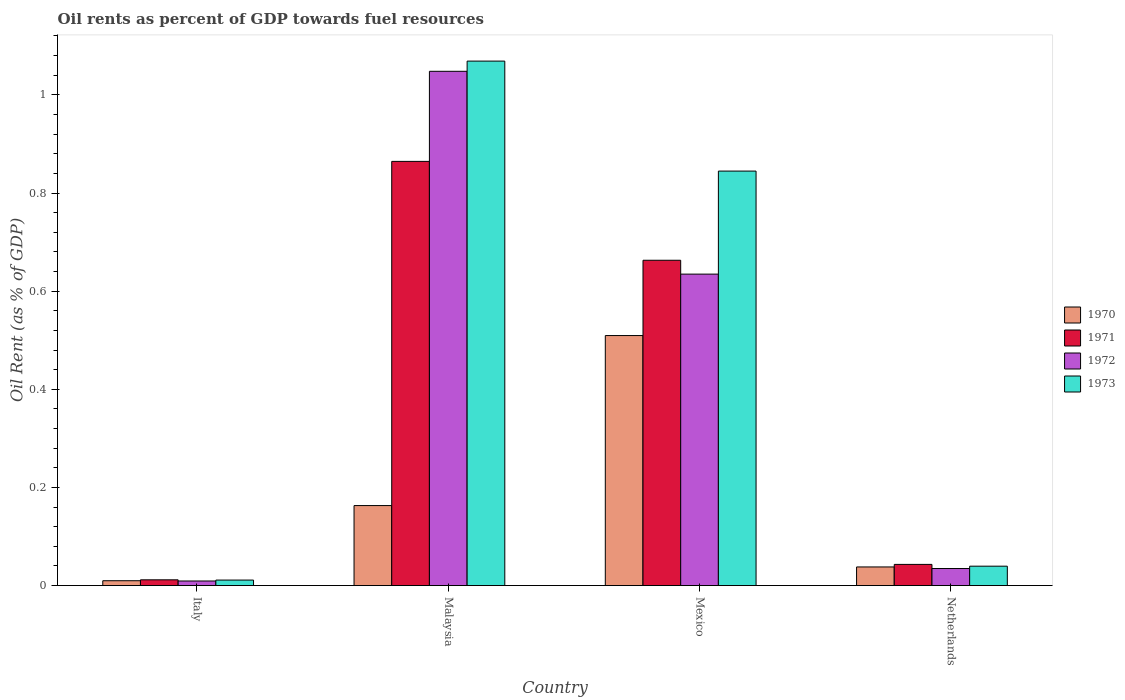Are the number of bars per tick equal to the number of legend labels?
Provide a succinct answer. Yes. Are the number of bars on each tick of the X-axis equal?
Ensure brevity in your answer.  Yes. How many bars are there on the 3rd tick from the left?
Keep it short and to the point. 4. What is the oil rent in 1972 in Italy?
Provide a short and direct response. 0.01. Across all countries, what is the maximum oil rent in 1970?
Offer a terse response. 0.51. Across all countries, what is the minimum oil rent in 1973?
Give a very brief answer. 0.01. In which country was the oil rent in 1972 maximum?
Offer a terse response. Malaysia. In which country was the oil rent in 1970 minimum?
Make the answer very short. Italy. What is the total oil rent in 1971 in the graph?
Make the answer very short. 1.58. What is the difference between the oil rent in 1971 in Malaysia and that in Netherlands?
Offer a terse response. 0.82. What is the difference between the oil rent in 1971 in Mexico and the oil rent in 1970 in Malaysia?
Provide a succinct answer. 0.5. What is the average oil rent in 1970 per country?
Give a very brief answer. 0.18. What is the difference between the oil rent of/in 1972 and oil rent of/in 1973 in Malaysia?
Offer a very short reply. -0.02. In how many countries, is the oil rent in 1971 greater than 0.6400000000000001 %?
Offer a terse response. 2. What is the ratio of the oil rent in 1970 in Italy to that in Netherlands?
Your answer should be compact. 0.26. Is the oil rent in 1971 in Mexico less than that in Netherlands?
Your answer should be very brief. No. Is the difference between the oil rent in 1972 in Mexico and Netherlands greater than the difference between the oil rent in 1973 in Mexico and Netherlands?
Keep it short and to the point. No. What is the difference between the highest and the second highest oil rent in 1971?
Provide a succinct answer. 0.2. What is the difference between the highest and the lowest oil rent in 1971?
Ensure brevity in your answer.  0.85. In how many countries, is the oil rent in 1971 greater than the average oil rent in 1971 taken over all countries?
Offer a very short reply. 2. Is it the case that in every country, the sum of the oil rent in 1971 and oil rent in 1970 is greater than the sum of oil rent in 1972 and oil rent in 1973?
Make the answer very short. No. What does the 2nd bar from the left in Netherlands represents?
Your answer should be compact. 1971. How many bars are there?
Offer a very short reply. 16. Are all the bars in the graph horizontal?
Your answer should be compact. No. How many countries are there in the graph?
Your answer should be very brief. 4. What is the difference between two consecutive major ticks on the Y-axis?
Offer a very short reply. 0.2. Does the graph contain grids?
Give a very brief answer. No. Where does the legend appear in the graph?
Give a very brief answer. Center right. How are the legend labels stacked?
Give a very brief answer. Vertical. What is the title of the graph?
Your answer should be compact. Oil rents as percent of GDP towards fuel resources. What is the label or title of the Y-axis?
Ensure brevity in your answer.  Oil Rent (as % of GDP). What is the Oil Rent (as % of GDP) of 1970 in Italy?
Your answer should be compact. 0.01. What is the Oil Rent (as % of GDP) of 1971 in Italy?
Ensure brevity in your answer.  0.01. What is the Oil Rent (as % of GDP) in 1972 in Italy?
Ensure brevity in your answer.  0.01. What is the Oil Rent (as % of GDP) of 1973 in Italy?
Your response must be concise. 0.01. What is the Oil Rent (as % of GDP) in 1970 in Malaysia?
Ensure brevity in your answer.  0.16. What is the Oil Rent (as % of GDP) in 1971 in Malaysia?
Offer a very short reply. 0.86. What is the Oil Rent (as % of GDP) in 1972 in Malaysia?
Ensure brevity in your answer.  1.05. What is the Oil Rent (as % of GDP) in 1973 in Malaysia?
Ensure brevity in your answer.  1.07. What is the Oil Rent (as % of GDP) of 1970 in Mexico?
Your response must be concise. 0.51. What is the Oil Rent (as % of GDP) of 1971 in Mexico?
Keep it short and to the point. 0.66. What is the Oil Rent (as % of GDP) of 1972 in Mexico?
Give a very brief answer. 0.63. What is the Oil Rent (as % of GDP) in 1973 in Mexico?
Give a very brief answer. 0.84. What is the Oil Rent (as % of GDP) in 1970 in Netherlands?
Give a very brief answer. 0.04. What is the Oil Rent (as % of GDP) of 1971 in Netherlands?
Your response must be concise. 0.04. What is the Oil Rent (as % of GDP) in 1972 in Netherlands?
Offer a very short reply. 0.03. What is the Oil Rent (as % of GDP) of 1973 in Netherlands?
Provide a succinct answer. 0.04. Across all countries, what is the maximum Oil Rent (as % of GDP) in 1970?
Provide a short and direct response. 0.51. Across all countries, what is the maximum Oil Rent (as % of GDP) in 1971?
Your answer should be very brief. 0.86. Across all countries, what is the maximum Oil Rent (as % of GDP) in 1972?
Your response must be concise. 1.05. Across all countries, what is the maximum Oil Rent (as % of GDP) in 1973?
Your answer should be very brief. 1.07. Across all countries, what is the minimum Oil Rent (as % of GDP) in 1970?
Your answer should be very brief. 0.01. Across all countries, what is the minimum Oil Rent (as % of GDP) in 1971?
Give a very brief answer. 0.01. Across all countries, what is the minimum Oil Rent (as % of GDP) in 1972?
Keep it short and to the point. 0.01. Across all countries, what is the minimum Oil Rent (as % of GDP) in 1973?
Give a very brief answer. 0.01. What is the total Oil Rent (as % of GDP) of 1970 in the graph?
Offer a terse response. 0.72. What is the total Oil Rent (as % of GDP) of 1971 in the graph?
Give a very brief answer. 1.58. What is the total Oil Rent (as % of GDP) of 1972 in the graph?
Offer a terse response. 1.73. What is the total Oil Rent (as % of GDP) in 1973 in the graph?
Your response must be concise. 1.96. What is the difference between the Oil Rent (as % of GDP) in 1970 in Italy and that in Malaysia?
Ensure brevity in your answer.  -0.15. What is the difference between the Oil Rent (as % of GDP) of 1971 in Italy and that in Malaysia?
Ensure brevity in your answer.  -0.85. What is the difference between the Oil Rent (as % of GDP) in 1972 in Italy and that in Malaysia?
Your answer should be very brief. -1.04. What is the difference between the Oil Rent (as % of GDP) of 1973 in Italy and that in Malaysia?
Your response must be concise. -1.06. What is the difference between the Oil Rent (as % of GDP) in 1970 in Italy and that in Mexico?
Your response must be concise. -0.5. What is the difference between the Oil Rent (as % of GDP) in 1971 in Italy and that in Mexico?
Your answer should be compact. -0.65. What is the difference between the Oil Rent (as % of GDP) in 1972 in Italy and that in Mexico?
Keep it short and to the point. -0.63. What is the difference between the Oil Rent (as % of GDP) of 1973 in Italy and that in Mexico?
Your answer should be compact. -0.83. What is the difference between the Oil Rent (as % of GDP) of 1970 in Italy and that in Netherlands?
Your answer should be very brief. -0.03. What is the difference between the Oil Rent (as % of GDP) in 1971 in Italy and that in Netherlands?
Make the answer very short. -0.03. What is the difference between the Oil Rent (as % of GDP) of 1972 in Italy and that in Netherlands?
Your answer should be very brief. -0.03. What is the difference between the Oil Rent (as % of GDP) in 1973 in Italy and that in Netherlands?
Your answer should be very brief. -0.03. What is the difference between the Oil Rent (as % of GDP) of 1970 in Malaysia and that in Mexico?
Ensure brevity in your answer.  -0.35. What is the difference between the Oil Rent (as % of GDP) of 1971 in Malaysia and that in Mexico?
Your answer should be compact. 0.2. What is the difference between the Oil Rent (as % of GDP) in 1972 in Malaysia and that in Mexico?
Offer a very short reply. 0.41. What is the difference between the Oil Rent (as % of GDP) in 1973 in Malaysia and that in Mexico?
Offer a terse response. 0.22. What is the difference between the Oil Rent (as % of GDP) in 1970 in Malaysia and that in Netherlands?
Offer a very short reply. 0.13. What is the difference between the Oil Rent (as % of GDP) in 1971 in Malaysia and that in Netherlands?
Offer a very short reply. 0.82. What is the difference between the Oil Rent (as % of GDP) of 1972 in Malaysia and that in Netherlands?
Keep it short and to the point. 1.01. What is the difference between the Oil Rent (as % of GDP) of 1973 in Malaysia and that in Netherlands?
Provide a short and direct response. 1.03. What is the difference between the Oil Rent (as % of GDP) in 1970 in Mexico and that in Netherlands?
Ensure brevity in your answer.  0.47. What is the difference between the Oil Rent (as % of GDP) of 1971 in Mexico and that in Netherlands?
Give a very brief answer. 0.62. What is the difference between the Oil Rent (as % of GDP) in 1973 in Mexico and that in Netherlands?
Your answer should be compact. 0.81. What is the difference between the Oil Rent (as % of GDP) of 1970 in Italy and the Oil Rent (as % of GDP) of 1971 in Malaysia?
Offer a terse response. -0.85. What is the difference between the Oil Rent (as % of GDP) of 1970 in Italy and the Oil Rent (as % of GDP) of 1972 in Malaysia?
Keep it short and to the point. -1.04. What is the difference between the Oil Rent (as % of GDP) in 1970 in Italy and the Oil Rent (as % of GDP) in 1973 in Malaysia?
Keep it short and to the point. -1.06. What is the difference between the Oil Rent (as % of GDP) in 1971 in Italy and the Oil Rent (as % of GDP) in 1972 in Malaysia?
Offer a very short reply. -1.04. What is the difference between the Oil Rent (as % of GDP) in 1971 in Italy and the Oil Rent (as % of GDP) in 1973 in Malaysia?
Your response must be concise. -1.06. What is the difference between the Oil Rent (as % of GDP) of 1972 in Italy and the Oil Rent (as % of GDP) of 1973 in Malaysia?
Offer a very short reply. -1.06. What is the difference between the Oil Rent (as % of GDP) of 1970 in Italy and the Oil Rent (as % of GDP) of 1971 in Mexico?
Ensure brevity in your answer.  -0.65. What is the difference between the Oil Rent (as % of GDP) of 1970 in Italy and the Oil Rent (as % of GDP) of 1972 in Mexico?
Your answer should be compact. -0.62. What is the difference between the Oil Rent (as % of GDP) in 1970 in Italy and the Oil Rent (as % of GDP) in 1973 in Mexico?
Provide a short and direct response. -0.83. What is the difference between the Oil Rent (as % of GDP) in 1971 in Italy and the Oil Rent (as % of GDP) in 1972 in Mexico?
Offer a very short reply. -0.62. What is the difference between the Oil Rent (as % of GDP) in 1971 in Italy and the Oil Rent (as % of GDP) in 1973 in Mexico?
Keep it short and to the point. -0.83. What is the difference between the Oil Rent (as % of GDP) of 1972 in Italy and the Oil Rent (as % of GDP) of 1973 in Mexico?
Give a very brief answer. -0.84. What is the difference between the Oil Rent (as % of GDP) of 1970 in Italy and the Oil Rent (as % of GDP) of 1971 in Netherlands?
Your response must be concise. -0.03. What is the difference between the Oil Rent (as % of GDP) of 1970 in Italy and the Oil Rent (as % of GDP) of 1972 in Netherlands?
Provide a succinct answer. -0.02. What is the difference between the Oil Rent (as % of GDP) in 1970 in Italy and the Oil Rent (as % of GDP) in 1973 in Netherlands?
Ensure brevity in your answer.  -0.03. What is the difference between the Oil Rent (as % of GDP) of 1971 in Italy and the Oil Rent (as % of GDP) of 1972 in Netherlands?
Your answer should be very brief. -0.02. What is the difference between the Oil Rent (as % of GDP) of 1971 in Italy and the Oil Rent (as % of GDP) of 1973 in Netherlands?
Your answer should be very brief. -0.03. What is the difference between the Oil Rent (as % of GDP) of 1972 in Italy and the Oil Rent (as % of GDP) of 1973 in Netherlands?
Give a very brief answer. -0.03. What is the difference between the Oil Rent (as % of GDP) of 1970 in Malaysia and the Oil Rent (as % of GDP) of 1971 in Mexico?
Your response must be concise. -0.5. What is the difference between the Oil Rent (as % of GDP) of 1970 in Malaysia and the Oil Rent (as % of GDP) of 1972 in Mexico?
Your answer should be very brief. -0.47. What is the difference between the Oil Rent (as % of GDP) in 1970 in Malaysia and the Oil Rent (as % of GDP) in 1973 in Mexico?
Provide a succinct answer. -0.68. What is the difference between the Oil Rent (as % of GDP) in 1971 in Malaysia and the Oil Rent (as % of GDP) in 1972 in Mexico?
Provide a short and direct response. 0.23. What is the difference between the Oil Rent (as % of GDP) in 1971 in Malaysia and the Oil Rent (as % of GDP) in 1973 in Mexico?
Offer a terse response. 0.02. What is the difference between the Oil Rent (as % of GDP) of 1972 in Malaysia and the Oil Rent (as % of GDP) of 1973 in Mexico?
Your response must be concise. 0.2. What is the difference between the Oil Rent (as % of GDP) in 1970 in Malaysia and the Oil Rent (as % of GDP) in 1971 in Netherlands?
Your answer should be compact. 0.12. What is the difference between the Oil Rent (as % of GDP) of 1970 in Malaysia and the Oil Rent (as % of GDP) of 1972 in Netherlands?
Give a very brief answer. 0.13. What is the difference between the Oil Rent (as % of GDP) of 1970 in Malaysia and the Oil Rent (as % of GDP) of 1973 in Netherlands?
Your answer should be compact. 0.12. What is the difference between the Oil Rent (as % of GDP) of 1971 in Malaysia and the Oil Rent (as % of GDP) of 1972 in Netherlands?
Your response must be concise. 0.83. What is the difference between the Oil Rent (as % of GDP) in 1971 in Malaysia and the Oil Rent (as % of GDP) in 1973 in Netherlands?
Your response must be concise. 0.82. What is the difference between the Oil Rent (as % of GDP) of 1972 in Malaysia and the Oil Rent (as % of GDP) of 1973 in Netherlands?
Provide a short and direct response. 1.01. What is the difference between the Oil Rent (as % of GDP) of 1970 in Mexico and the Oil Rent (as % of GDP) of 1971 in Netherlands?
Your answer should be compact. 0.47. What is the difference between the Oil Rent (as % of GDP) in 1970 in Mexico and the Oil Rent (as % of GDP) in 1972 in Netherlands?
Offer a terse response. 0.47. What is the difference between the Oil Rent (as % of GDP) of 1970 in Mexico and the Oil Rent (as % of GDP) of 1973 in Netherlands?
Make the answer very short. 0.47. What is the difference between the Oil Rent (as % of GDP) of 1971 in Mexico and the Oil Rent (as % of GDP) of 1972 in Netherlands?
Offer a very short reply. 0.63. What is the difference between the Oil Rent (as % of GDP) in 1971 in Mexico and the Oil Rent (as % of GDP) in 1973 in Netherlands?
Offer a very short reply. 0.62. What is the difference between the Oil Rent (as % of GDP) in 1972 in Mexico and the Oil Rent (as % of GDP) in 1973 in Netherlands?
Offer a very short reply. 0.6. What is the average Oil Rent (as % of GDP) of 1970 per country?
Provide a succinct answer. 0.18. What is the average Oil Rent (as % of GDP) of 1971 per country?
Your response must be concise. 0.4. What is the average Oil Rent (as % of GDP) in 1972 per country?
Give a very brief answer. 0.43. What is the average Oil Rent (as % of GDP) of 1973 per country?
Provide a succinct answer. 0.49. What is the difference between the Oil Rent (as % of GDP) in 1970 and Oil Rent (as % of GDP) in 1971 in Italy?
Your answer should be compact. -0. What is the difference between the Oil Rent (as % of GDP) in 1970 and Oil Rent (as % of GDP) in 1972 in Italy?
Your answer should be very brief. 0. What is the difference between the Oil Rent (as % of GDP) in 1970 and Oil Rent (as % of GDP) in 1973 in Italy?
Your answer should be very brief. -0. What is the difference between the Oil Rent (as % of GDP) in 1971 and Oil Rent (as % of GDP) in 1972 in Italy?
Your response must be concise. 0. What is the difference between the Oil Rent (as % of GDP) of 1971 and Oil Rent (as % of GDP) of 1973 in Italy?
Ensure brevity in your answer.  0. What is the difference between the Oil Rent (as % of GDP) of 1972 and Oil Rent (as % of GDP) of 1973 in Italy?
Make the answer very short. -0. What is the difference between the Oil Rent (as % of GDP) in 1970 and Oil Rent (as % of GDP) in 1971 in Malaysia?
Provide a succinct answer. -0.7. What is the difference between the Oil Rent (as % of GDP) in 1970 and Oil Rent (as % of GDP) in 1972 in Malaysia?
Provide a succinct answer. -0.89. What is the difference between the Oil Rent (as % of GDP) in 1970 and Oil Rent (as % of GDP) in 1973 in Malaysia?
Keep it short and to the point. -0.91. What is the difference between the Oil Rent (as % of GDP) in 1971 and Oil Rent (as % of GDP) in 1972 in Malaysia?
Offer a terse response. -0.18. What is the difference between the Oil Rent (as % of GDP) of 1971 and Oil Rent (as % of GDP) of 1973 in Malaysia?
Offer a terse response. -0.2. What is the difference between the Oil Rent (as % of GDP) in 1972 and Oil Rent (as % of GDP) in 1973 in Malaysia?
Keep it short and to the point. -0.02. What is the difference between the Oil Rent (as % of GDP) in 1970 and Oil Rent (as % of GDP) in 1971 in Mexico?
Ensure brevity in your answer.  -0.15. What is the difference between the Oil Rent (as % of GDP) in 1970 and Oil Rent (as % of GDP) in 1972 in Mexico?
Your response must be concise. -0.13. What is the difference between the Oil Rent (as % of GDP) of 1970 and Oil Rent (as % of GDP) of 1973 in Mexico?
Your answer should be very brief. -0.34. What is the difference between the Oil Rent (as % of GDP) of 1971 and Oil Rent (as % of GDP) of 1972 in Mexico?
Keep it short and to the point. 0.03. What is the difference between the Oil Rent (as % of GDP) in 1971 and Oil Rent (as % of GDP) in 1973 in Mexico?
Your response must be concise. -0.18. What is the difference between the Oil Rent (as % of GDP) of 1972 and Oil Rent (as % of GDP) of 1973 in Mexico?
Ensure brevity in your answer.  -0.21. What is the difference between the Oil Rent (as % of GDP) of 1970 and Oil Rent (as % of GDP) of 1971 in Netherlands?
Keep it short and to the point. -0.01. What is the difference between the Oil Rent (as % of GDP) in 1970 and Oil Rent (as % of GDP) in 1972 in Netherlands?
Provide a succinct answer. 0. What is the difference between the Oil Rent (as % of GDP) of 1970 and Oil Rent (as % of GDP) of 1973 in Netherlands?
Provide a short and direct response. -0. What is the difference between the Oil Rent (as % of GDP) of 1971 and Oil Rent (as % of GDP) of 1972 in Netherlands?
Your response must be concise. 0.01. What is the difference between the Oil Rent (as % of GDP) in 1971 and Oil Rent (as % of GDP) in 1973 in Netherlands?
Offer a terse response. 0. What is the difference between the Oil Rent (as % of GDP) of 1972 and Oil Rent (as % of GDP) of 1973 in Netherlands?
Your response must be concise. -0. What is the ratio of the Oil Rent (as % of GDP) of 1970 in Italy to that in Malaysia?
Make the answer very short. 0.06. What is the ratio of the Oil Rent (as % of GDP) in 1971 in Italy to that in Malaysia?
Keep it short and to the point. 0.01. What is the ratio of the Oil Rent (as % of GDP) of 1972 in Italy to that in Malaysia?
Provide a short and direct response. 0.01. What is the ratio of the Oil Rent (as % of GDP) in 1973 in Italy to that in Malaysia?
Make the answer very short. 0.01. What is the ratio of the Oil Rent (as % of GDP) of 1970 in Italy to that in Mexico?
Give a very brief answer. 0.02. What is the ratio of the Oil Rent (as % of GDP) in 1971 in Italy to that in Mexico?
Your answer should be very brief. 0.02. What is the ratio of the Oil Rent (as % of GDP) of 1972 in Italy to that in Mexico?
Provide a short and direct response. 0.01. What is the ratio of the Oil Rent (as % of GDP) of 1973 in Italy to that in Mexico?
Keep it short and to the point. 0.01. What is the ratio of the Oil Rent (as % of GDP) in 1970 in Italy to that in Netherlands?
Provide a short and direct response. 0.26. What is the ratio of the Oil Rent (as % of GDP) in 1971 in Italy to that in Netherlands?
Your response must be concise. 0.27. What is the ratio of the Oil Rent (as % of GDP) of 1972 in Italy to that in Netherlands?
Provide a succinct answer. 0.27. What is the ratio of the Oil Rent (as % of GDP) of 1973 in Italy to that in Netherlands?
Your answer should be very brief. 0.28. What is the ratio of the Oil Rent (as % of GDP) in 1970 in Malaysia to that in Mexico?
Your answer should be very brief. 0.32. What is the ratio of the Oil Rent (as % of GDP) of 1971 in Malaysia to that in Mexico?
Give a very brief answer. 1.3. What is the ratio of the Oil Rent (as % of GDP) of 1972 in Malaysia to that in Mexico?
Provide a succinct answer. 1.65. What is the ratio of the Oil Rent (as % of GDP) in 1973 in Malaysia to that in Mexico?
Provide a short and direct response. 1.27. What is the ratio of the Oil Rent (as % of GDP) of 1970 in Malaysia to that in Netherlands?
Ensure brevity in your answer.  4.3. What is the ratio of the Oil Rent (as % of GDP) in 1971 in Malaysia to that in Netherlands?
Give a very brief answer. 20.04. What is the ratio of the Oil Rent (as % of GDP) of 1972 in Malaysia to that in Netherlands?
Make the answer very short. 30.19. What is the ratio of the Oil Rent (as % of GDP) in 1973 in Malaysia to that in Netherlands?
Make the answer very short. 27.06. What is the ratio of the Oil Rent (as % of GDP) of 1970 in Mexico to that in Netherlands?
Keep it short and to the point. 13.43. What is the ratio of the Oil Rent (as % of GDP) of 1971 in Mexico to that in Netherlands?
Ensure brevity in your answer.  15.37. What is the ratio of the Oil Rent (as % of GDP) in 1972 in Mexico to that in Netherlands?
Your response must be concise. 18.28. What is the ratio of the Oil Rent (as % of GDP) in 1973 in Mexico to that in Netherlands?
Your answer should be compact. 21.38. What is the difference between the highest and the second highest Oil Rent (as % of GDP) in 1970?
Your answer should be compact. 0.35. What is the difference between the highest and the second highest Oil Rent (as % of GDP) of 1971?
Offer a very short reply. 0.2. What is the difference between the highest and the second highest Oil Rent (as % of GDP) of 1972?
Ensure brevity in your answer.  0.41. What is the difference between the highest and the second highest Oil Rent (as % of GDP) of 1973?
Provide a succinct answer. 0.22. What is the difference between the highest and the lowest Oil Rent (as % of GDP) in 1970?
Provide a short and direct response. 0.5. What is the difference between the highest and the lowest Oil Rent (as % of GDP) in 1971?
Your answer should be compact. 0.85. What is the difference between the highest and the lowest Oil Rent (as % of GDP) of 1972?
Your answer should be very brief. 1.04. What is the difference between the highest and the lowest Oil Rent (as % of GDP) of 1973?
Your response must be concise. 1.06. 